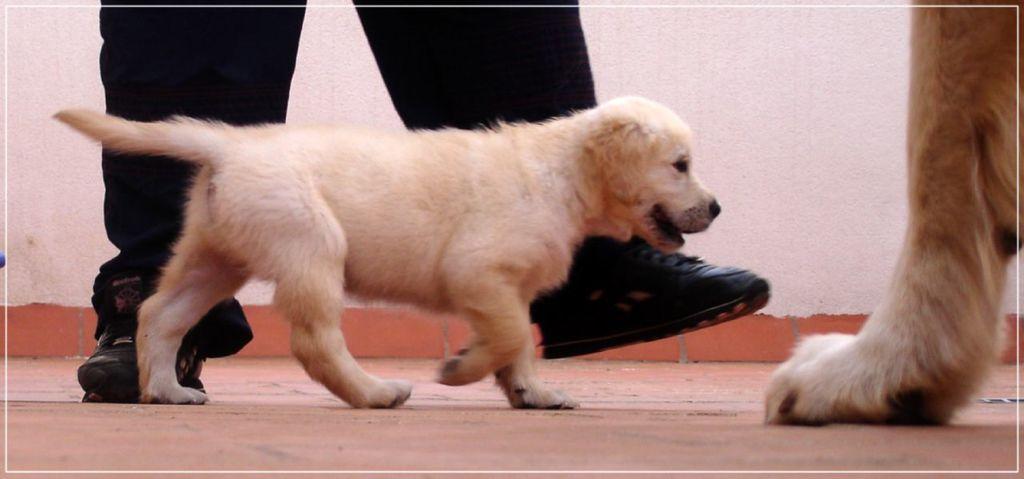Describe this image in one or two sentences. This is a photo. In the center of the image we can see a person legs and a dog is walking. On the right side of the image we can see an animal leg. In the background of the image we can see the wall. At the bottom of the image we can see the floor. 